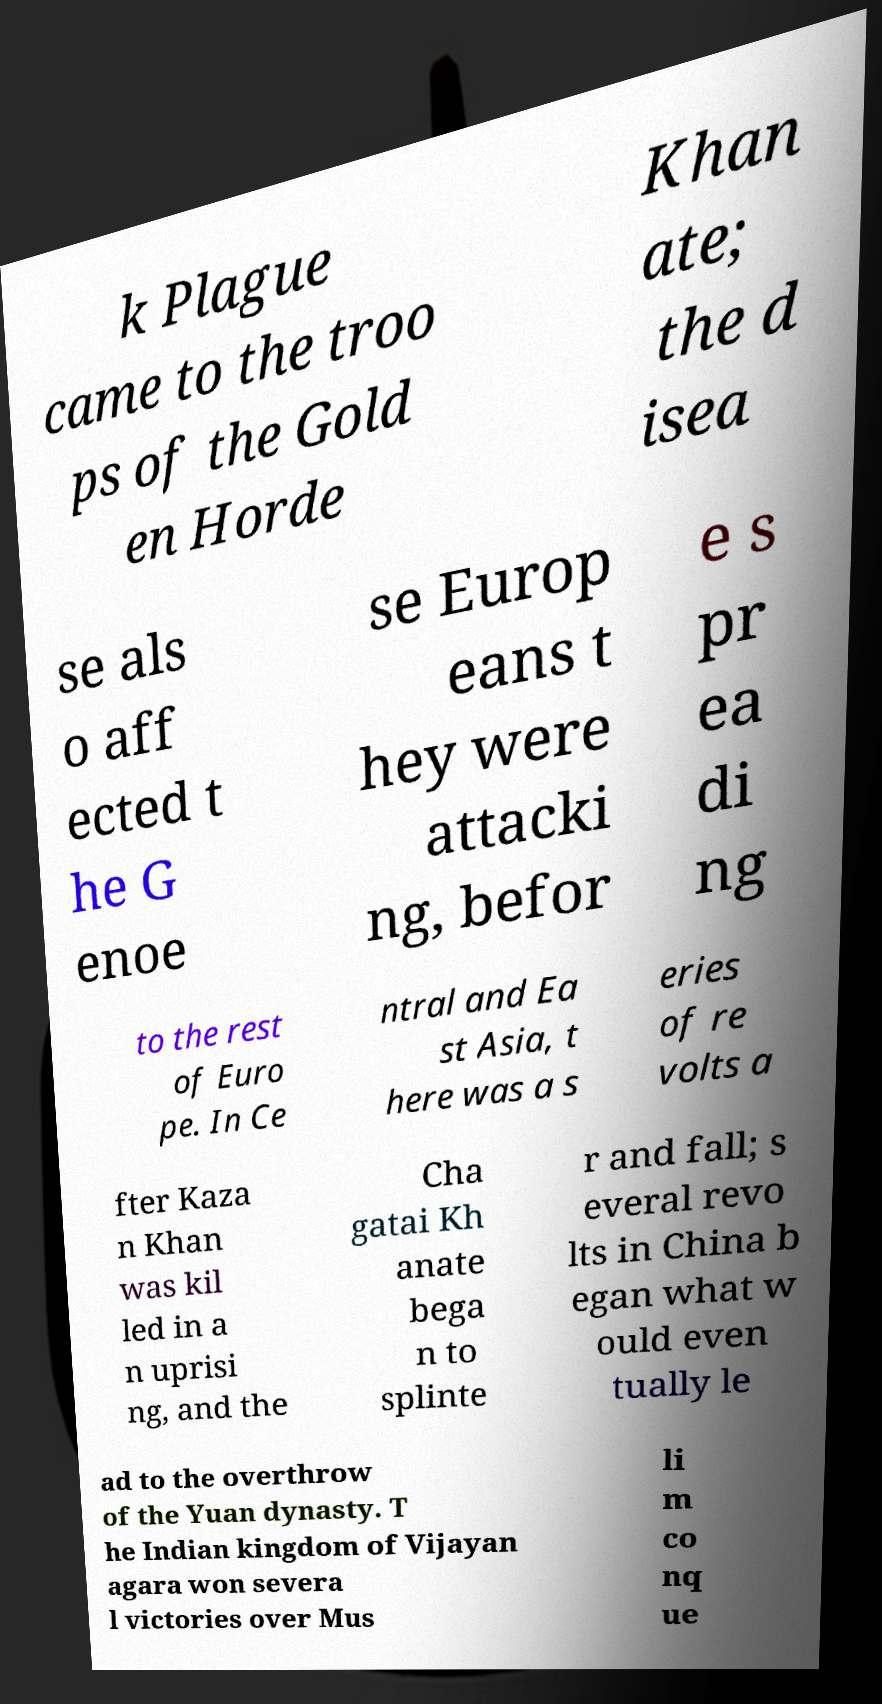For documentation purposes, I need the text within this image transcribed. Could you provide that? k Plague came to the troo ps of the Gold en Horde Khan ate; the d isea se als o aff ected t he G enoe se Europ eans t hey were attacki ng, befor e s pr ea di ng to the rest of Euro pe. In Ce ntral and Ea st Asia, t here was a s eries of re volts a fter Kaza n Khan was kil led in a n uprisi ng, and the Cha gatai Kh anate bega n to splinte r and fall; s everal revo lts in China b egan what w ould even tually le ad to the overthrow of the Yuan dynasty. T he Indian kingdom of Vijayan agara won severa l victories over Mus li m co nq ue 